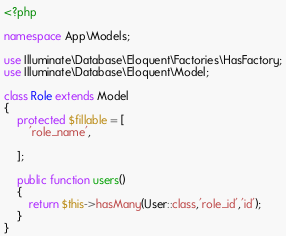<code> <loc_0><loc_0><loc_500><loc_500><_PHP_><?php

namespace App\Models;

use Illuminate\Database\Eloquent\Factories\HasFactory;
use Illuminate\Database\Eloquent\Model;

class Role extends Model
{
    protected $fillable = [
        'role_name',
        
    ];

    public function users()
    {
        return $this->hasMany(User::class,'role_id','id');
    }
}
</code> 